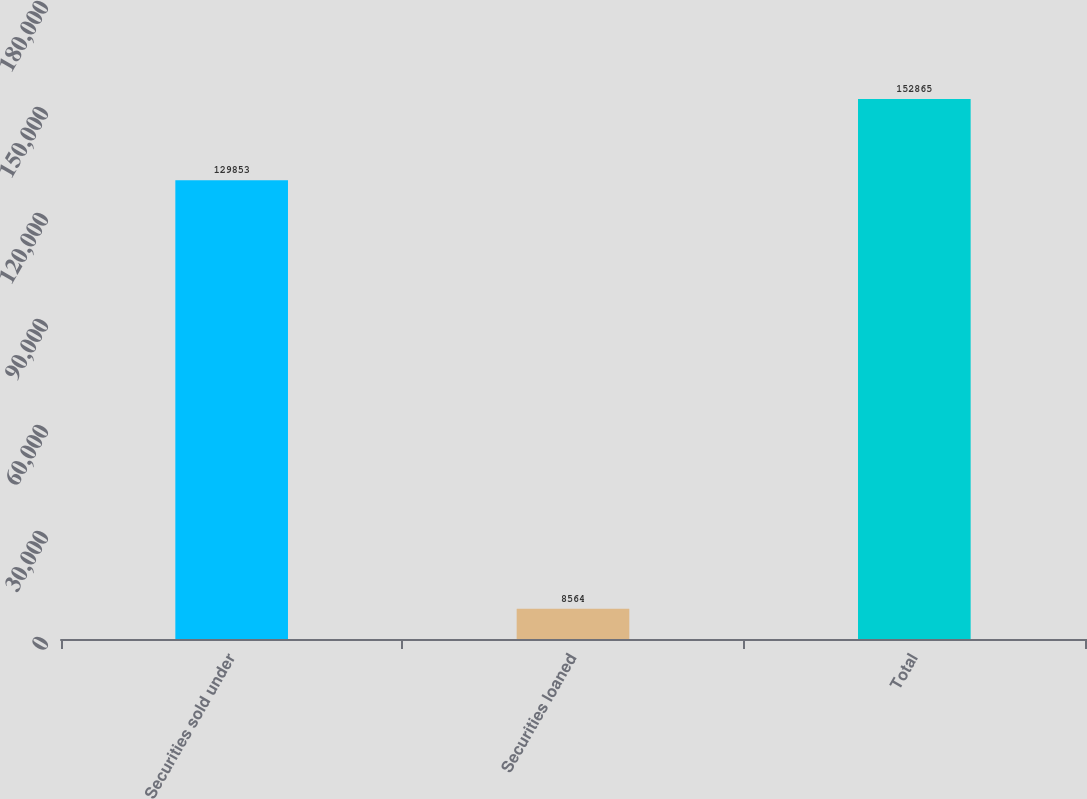Convert chart. <chart><loc_0><loc_0><loc_500><loc_500><bar_chart><fcel>Securities sold under<fcel>Securities loaned<fcel>Total<nl><fcel>129853<fcel>8564<fcel>152865<nl></chart> 